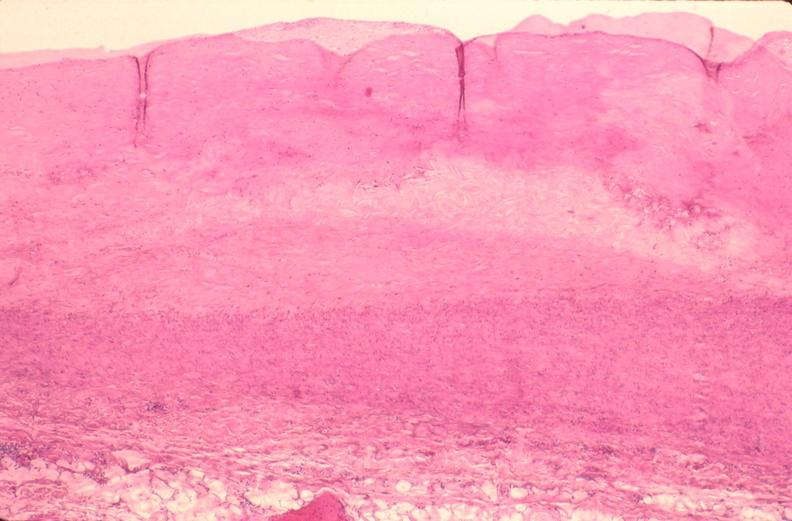s this present?
Answer the question using a single word or phrase. No 